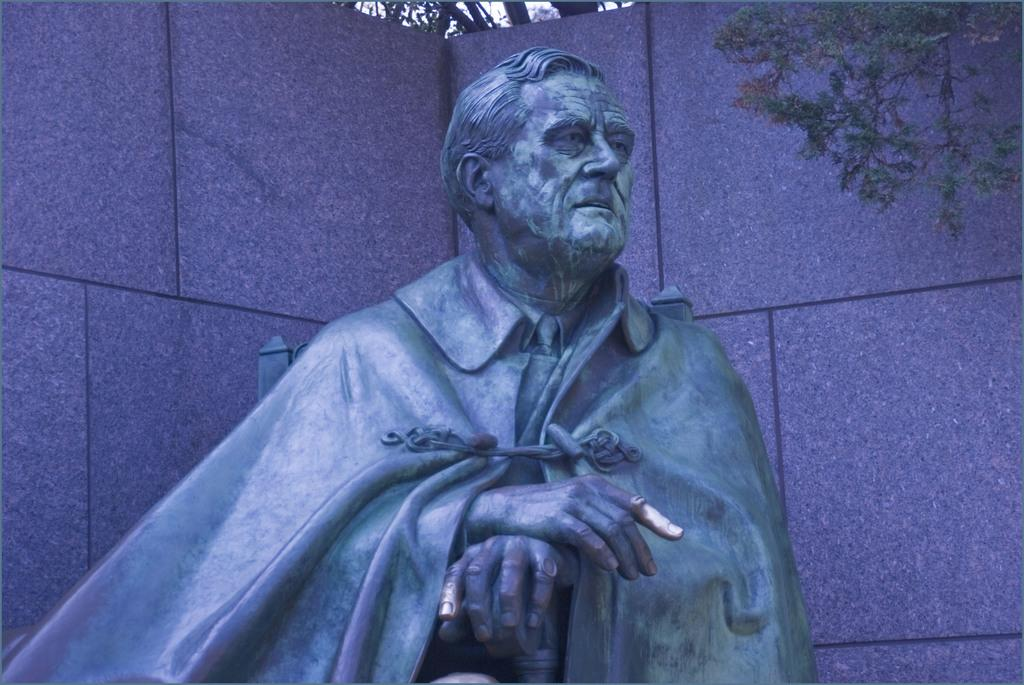What is the main subject of the image? There is a statue of a man in the image. What else can be seen in the background of the image? There is a wall and a tree with branches and leaves in the image. What color is the crayon used to draw the pear in the image? There is no crayon or pear present in the image. What is the taste of the fruit depicted in the image? There is no fruit depicted in the image. 